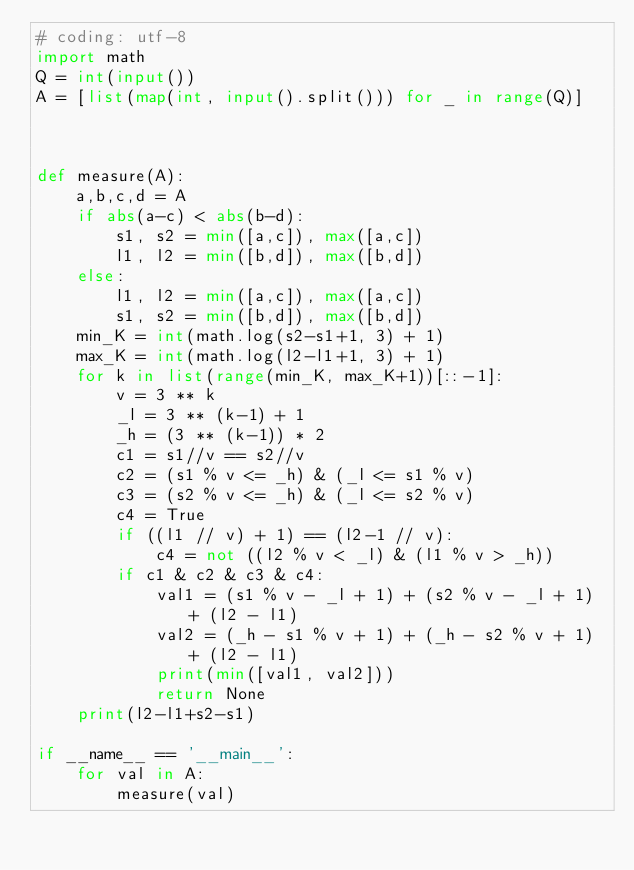<code> <loc_0><loc_0><loc_500><loc_500><_Python_># coding: utf-8
import math
Q = int(input())
A = [list(map(int, input().split())) for _ in range(Q)]



def measure(A):
    a,b,c,d = A
    if abs(a-c) < abs(b-d):
        s1, s2 = min([a,c]), max([a,c])
        l1, l2 = min([b,d]), max([b,d])
    else:
        l1, l2 = min([a,c]), max([a,c])
        s1, s2 = min([b,d]), max([b,d])
    min_K = int(math.log(s2-s1+1, 3) + 1)
    max_K = int(math.log(l2-l1+1, 3) + 1)
    for k in list(range(min_K, max_K+1))[::-1]:
        v = 3 ** k
        _l = 3 ** (k-1) + 1
        _h = (3 ** (k-1)) * 2
        c1 = s1//v == s2//v
        c2 = (s1 % v <= _h) & (_l <= s1 % v)
        c3 = (s2 % v <= _h) & (_l <= s2 % v)
        c4 = True
        if ((l1 // v) + 1) == (l2-1 // v):
            c4 = not ((l2 % v < _l) & (l1 % v > _h))
        if c1 & c2 & c3 & c4:
            val1 = (s1 % v - _l + 1) + (s2 % v - _l + 1) + (l2 - l1)
            val2 = (_h - s1 % v + 1) + (_h - s2 % v + 1) + (l2 - l1)
            print(min([val1, val2]))
            return None
    print(l2-l1+s2-s1)

if __name__ == '__main__':
    for val in A:
        measure(val)</code> 